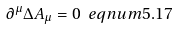<formula> <loc_0><loc_0><loc_500><loc_500>\partial ^ { \mu } \Delta A _ { \mu } = 0 \ e q n u m { 5 . 1 7 }</formula> 